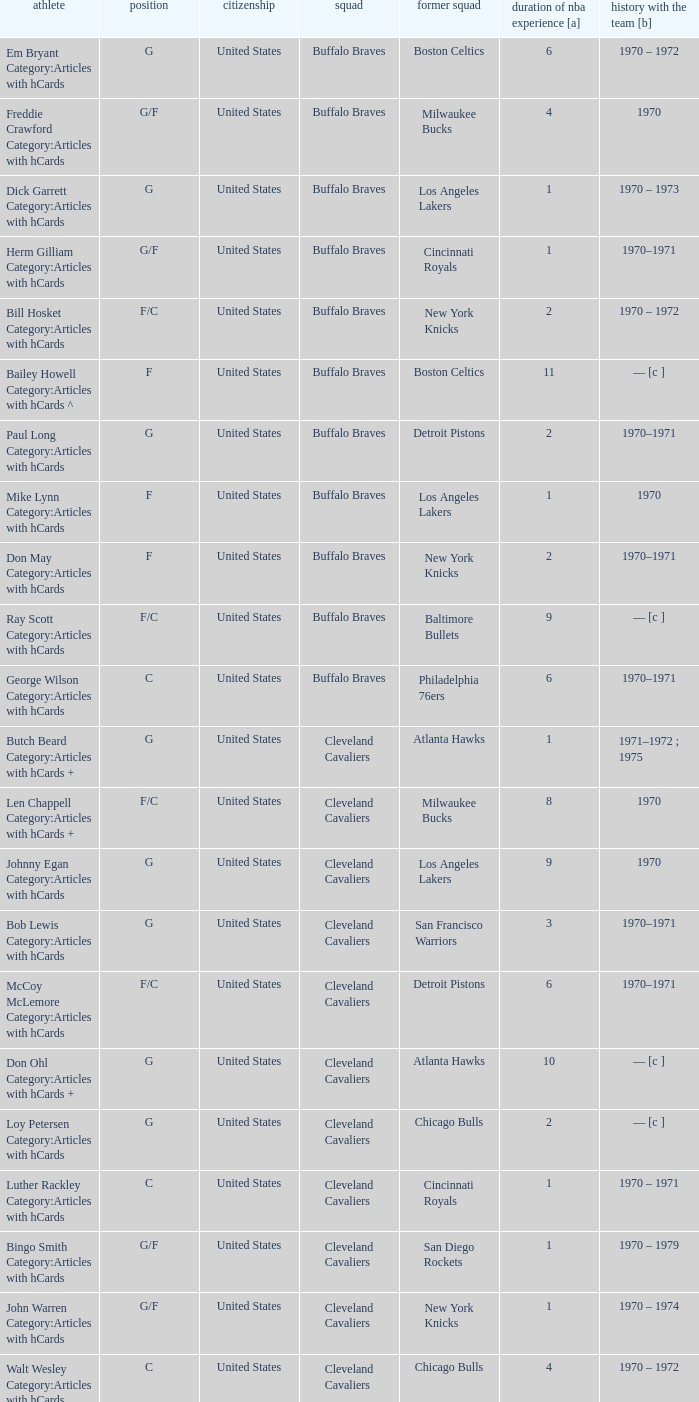How many years of NBA experience does the player who plays position g for the Portland Trail Blazers? 2.0. Give me the full table as a dictionary. {'header': ['athlete', 'position', 'citizenship', 'squad', 'former squad', 'duration of nba experience [a]', 'history with the team [b]'], 'rows': [['Em Bryant Category:Articles with hCards', 'G', 'United States', 'Buffalo Braves', 'Boston Celtics', '6', '1970 – 1972'], ['Freddie Crawford Category:Articles with hCards', 'G/F', 'United States', 'Buffalo Braves', 'Milwaukee Bucks', '4', '1970'], ['Dick Garrett Category:Articles with hCards', 'G', 'United States', 'Buffalo Braves', 'Los Angeles Lakers', '1', '1970 – 1973'], ['Herm Gilliam Category:Articles with hCards', 'G/F', 'United States', 'Buffalo Braves', 'Cincinnati Royals', '1', '1970–1971'], ['Bill Hosket Category:Articles with hCards', 'F/C', 'United States', 'Buffalo Braves', 'New York Knicks', '2', '1970 – 1972'], ['Bailey Howell Category:Articles with hCards ^', 'F', 'United States', 'Buffalo Braves', 'Boston Celtics', '11', '— [c ]'], ['Paul Long Category:Articles with hCards', 'G', 'United States', 'Buffalo Braves', 'Detroit Pistons', '2', '1970–1971'], ['Mike Lynn Category:Articles with hCards', 'F', 'United States', 'Buffalo Braves', 'Los Angeles Lakers', '1', '1970'], ['Don May Category:Articles with hCards', 'F', 'United States', 'Buffalo Braves', 'New York Knicks', '2', '1970–1971'], ['Ray Scott Category:Articles with hCards', 'F/C', 'United States', 'Buffalo Braves', 'Baltimore Bullets', '9', '— [c ]'], ['George Wilson Category:Articles with hCards', 'C', 'United States', 'Buffalo Braves', 'Philadelphia 76ers', '6', '1970–1971'], ['Butch Beard Category:Articles with hCards +', 'G', 'United States', 'Cleveland Cavaliers', 'Atlanta Hawks', '1', '1971–1972 ; 1975'], ['Len Chappell Category:Articles with hCards +', 'F/C', 'United States', 'Cleveland Cavaliers', 'Milwaukee Bucks', '8', '1970'], ['Johnny Egan Category:Articles with hCards', 'G', 'United States', 'Cleveland Cavaliers', 'Los Angeles Lakers', '9', '1970'], ['Bob Lewis Category:Articles with hCards', 'G', 'United States', 'Cleveland Cavaliers', 'San Francisco Warriors', '3', '1970–1971'], ['McCoy McLemore Category:Articles with hCards', 'F/C', 'United States', 'Cleveland Cavaliers', 'Detroit Pistons', '6', '1970–1971'], ['Don Ohl Category:Articles with hCards +', 'G', 'United States', 'Cleveland Cavaliers', 'Atlanta Hawks', '10', '— [c ]'], ['Loy Petersen Category:Articles with hCards', 'G', 'United States', 'Cleveland Cavaliers', 'Chicago Bulls', '2', '— [c ]'], ['Luther Rackley Category:Articles with hCards', 'C', 'United States', 'Cleveland Cavaliers', 'Cincinnati Royals', '1', '1970 – 1971'], ['Bingo Smith Category:Articles with hCards', 'G/F', 'United States', 'Cleveland Cavaliers', 'San Diego Rockets', '1', '1970 – 1979'], ['John Warren Category:Articles with hCards', 'G/F', 'United States', 'Cleveland Cavaliers', 'New York Knicks', '1', '1970 – 1974'], ['Walt Wesley Category:Articles with hCards', 'C', 'United States', 'Cleveland Cavaliers', 'Chicago Bulls', '4', '1970 – 1972'], ['Rick Adelman Category:Articles with hCards', 'G', 'United States', 'Portland Trail Blazers', 'San Diego Rockets', '2', '1970 – 1973'], ['Jerry Chambers Category:Articles with hCards', 'F', 'United States', 'Portland Trail Blazers', 'Phoenix Suns', '2', '— [c ]'], ['LeRoy Ellis Category:Articles with hCards', 'F/C', 'United States', 'Portland Trail Blazers', 'Baltimore Bullets', '8', '1970–1971'], ['Fred Hetzel Category:Articles with hCards', 'F/C', 'United States', 'Portland Trail Blazers', 'Philadelphia 76ers', '5', '— [c ]'], ['Joe Kennedy Category:Articles with hCards', 'F', 'United States', 'Portland Trail Blazers', 'Seattle SuperSonics', '2', '— [c ]'], ['Ed Manning Category:Articles with hCards', 'F', 'United States', 'Portland Trail Blazers', 'Chicago Bulls', '3', '1970–1971'], ['Stan McKenzie Category:Articles with hCards', 'G/F', 'United States', 'Portland Trail Blazers', 'Phoenix Suns', '3', '1970 – 1972'], ['Dorie Murrey Category:Articles with hCards', 'F/C', 'United States', 'Portland Trail Blazers', 'Seattle SuperSonics', '4', '1970'], ['Pat Riley Category:Articles with hCards', 'G/F', 'United States', 'Portland Trail Blazers', 'San Diego Rockets', '3', '— [c ]'], ['Dale Schlueter Category:Articles with hCards', 'C', 'United States', 'Portland Trail Blazers', 'San Francisco Warriors', '2', '1970 – 1972 ; 1977–1978'], ['Larry Siegfried Category:Articles with hCards', 'F', 'United States', 'Portland Trail Blazers', 'Boston Celtics', '7', '— [c ]']]} 